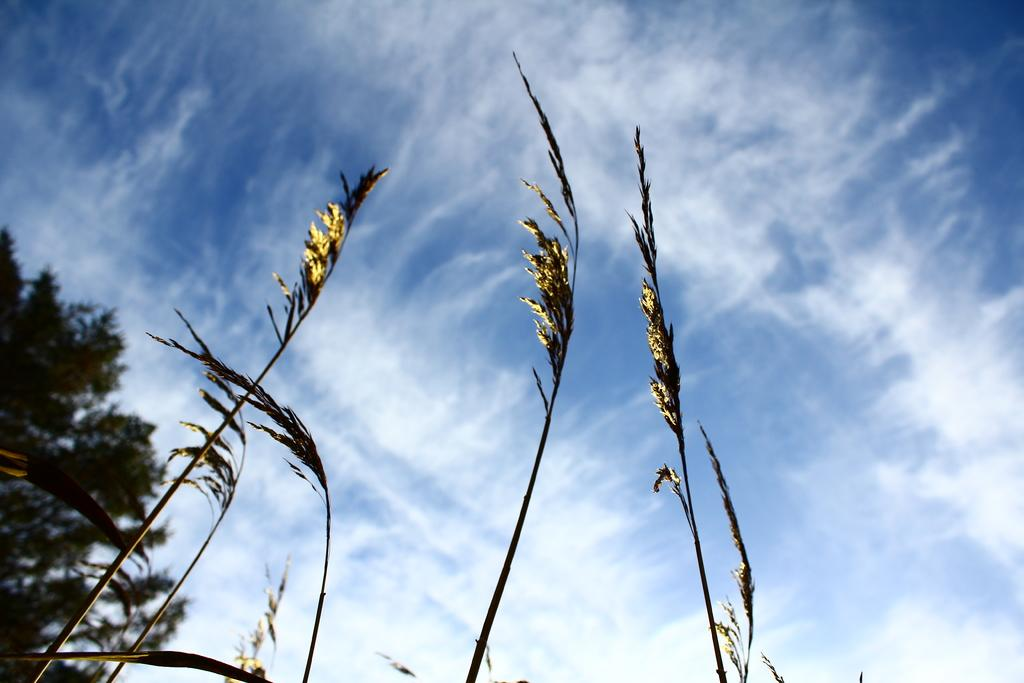What type of vegetation is present in the image? There are plants and trees in the image. What is visible in the sky in the image? The sky is clear in the image. How does the visitor interact with the plants in the image? There is no visitor present in the image, so it is not possible to determine how they might interact with the plants. What is located in the middle of the image? The facts provided do not specify any particular object or subject being located in the middle of the image. 